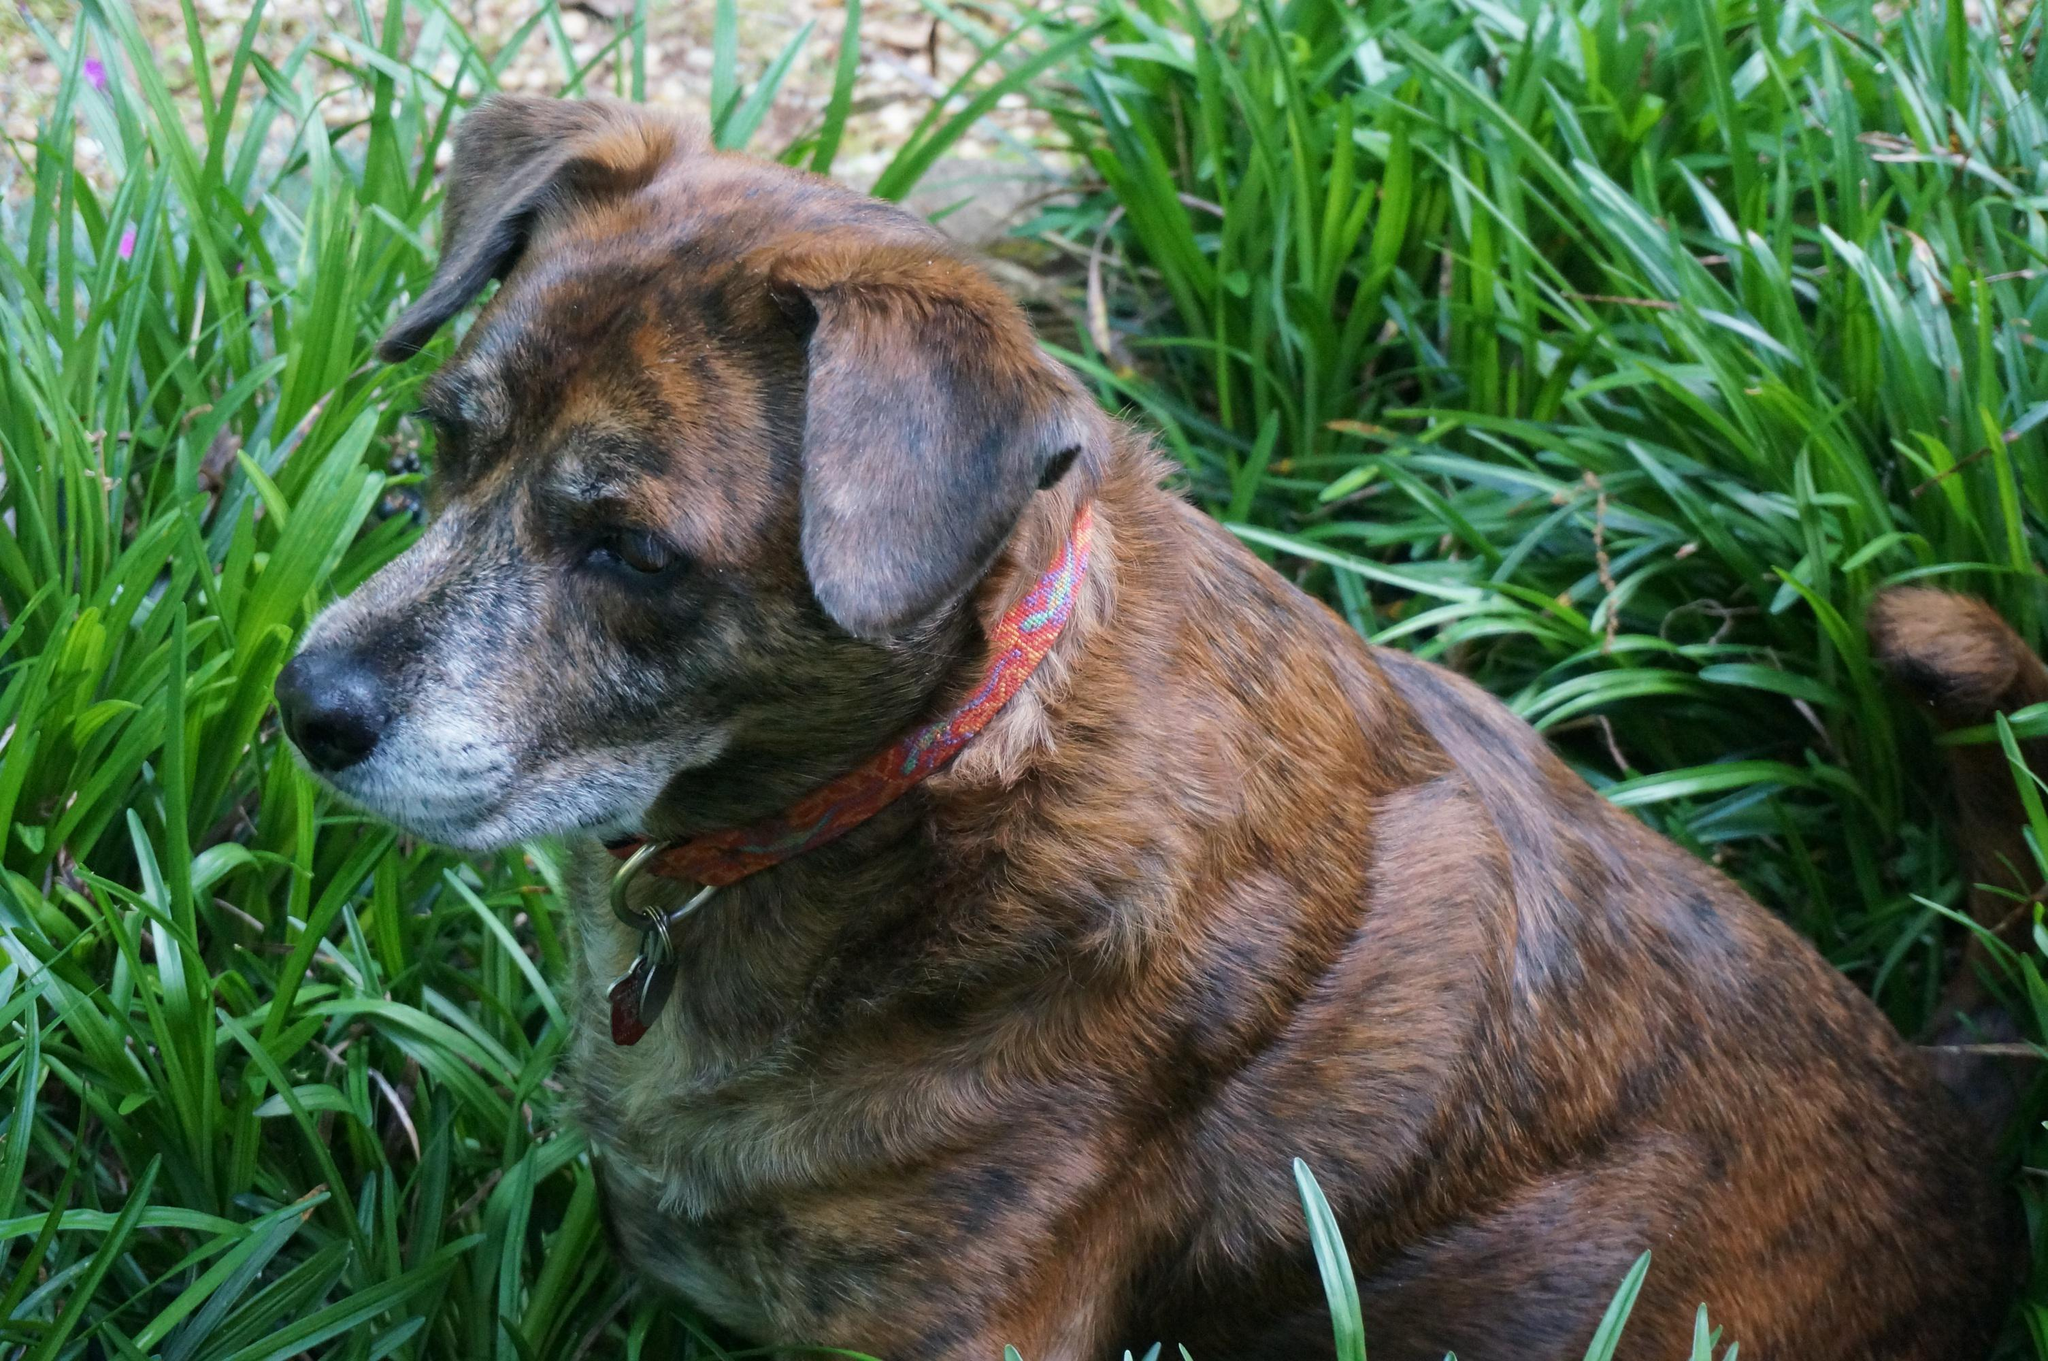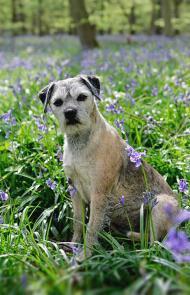The first image is the image on the left, the second image is the image on the right. Assess this claim about the two images: "The right image contains one dog standing in the grass with its tail hanging down, its mouth open, and something around its neck.". Correct or not? Answer yes or no. No. The first image is the image on the left, the second image is the image on the right. Analyze the images presented: Is the assertion "There is exactly one dog in every photo and no dogs have their mouths open." valid? Answer yes or no. Yes. 